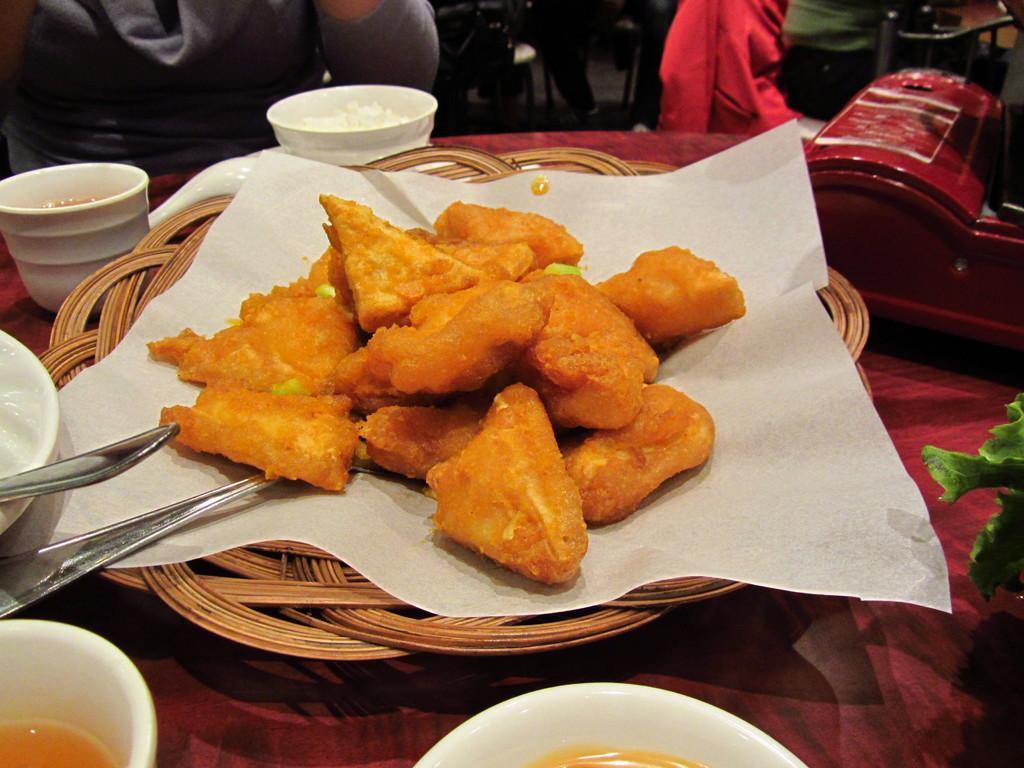Please provide a concise description of this image. In this image there is a plate having a paper. Some food and a spoon kept on the paper. Left side there is a bowl, having a spoon in it. There are bowls and an object kept on the table. Left top there is a person. Right top there is a chair. Top of the image few people are sitting on the hairs. Left side a leafy vegetable is visible. 